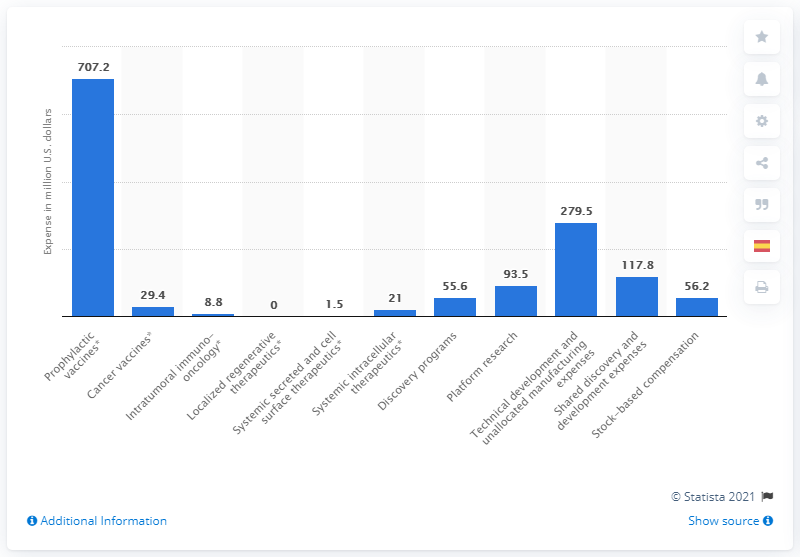Specify some key components in this picture. Moderna spent approximately $707.2 million on vaccines in 2020. 